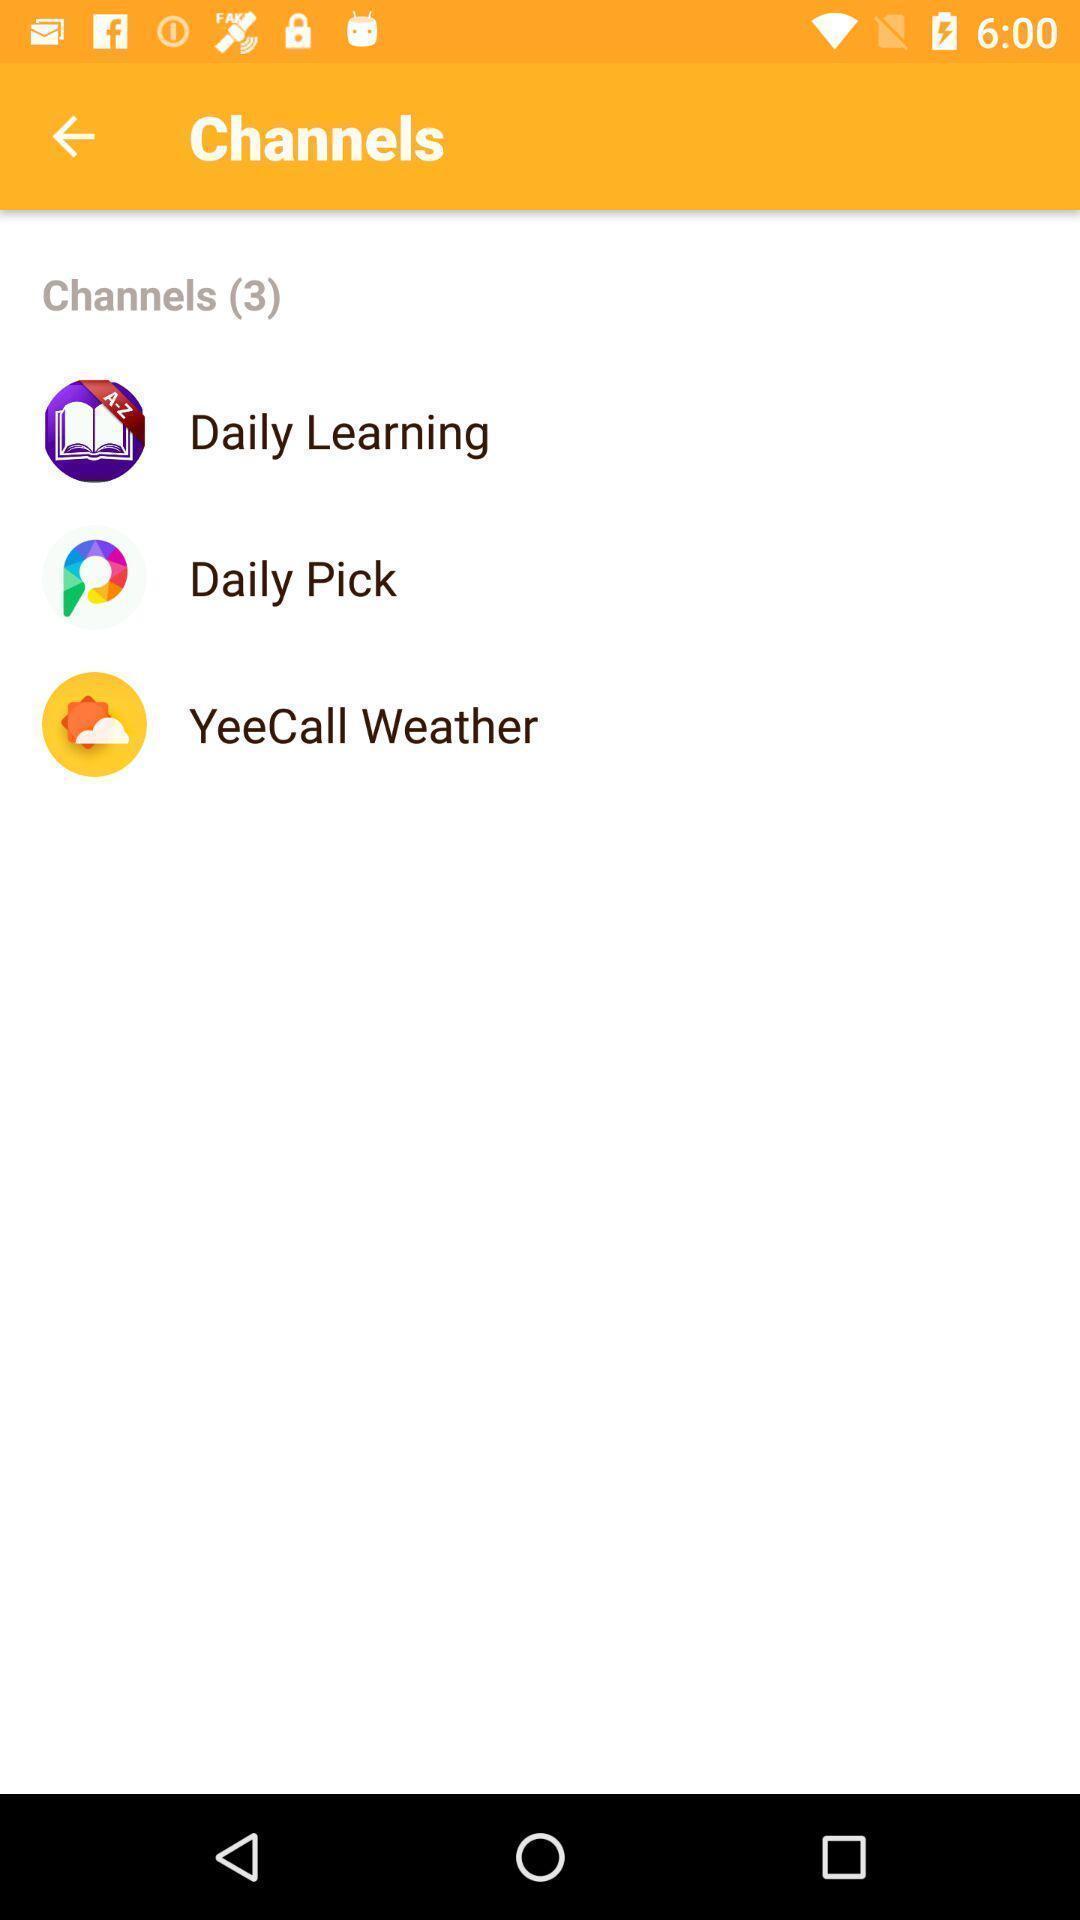Provide a textual representation of this image. Screen displaying list of channels. 